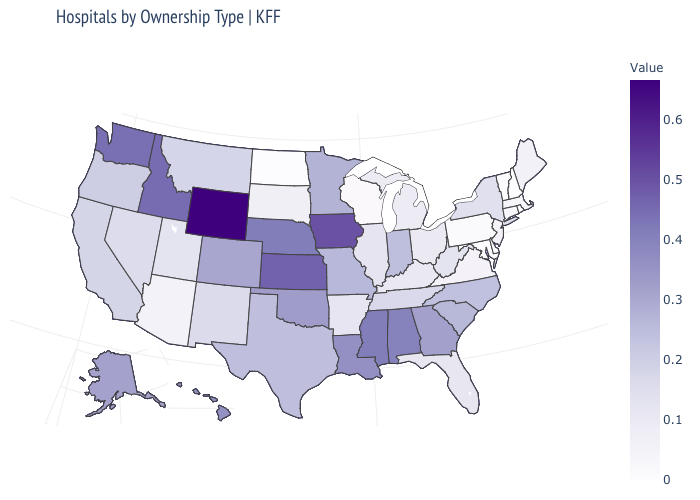Does New Jersey have the highest value in the Northeast?
Keep it brief. No. Among the states that border Arizona , which have the highest value?
Answer briefly. Colorado. Does Ohio have a lower value than Wyoming?
Keep it brief. Yes. Is the legend a continuous bar?
Concise answer only. Yes. Which states have the highest value in the USA?
Quick response, please. Wyoming. 